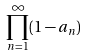<formula> <loc_0><loc_0><loc_500><loc_500>\prod _ { n = 1 } ^ { \infty } ( 1 - a _ { n } )</formula> 